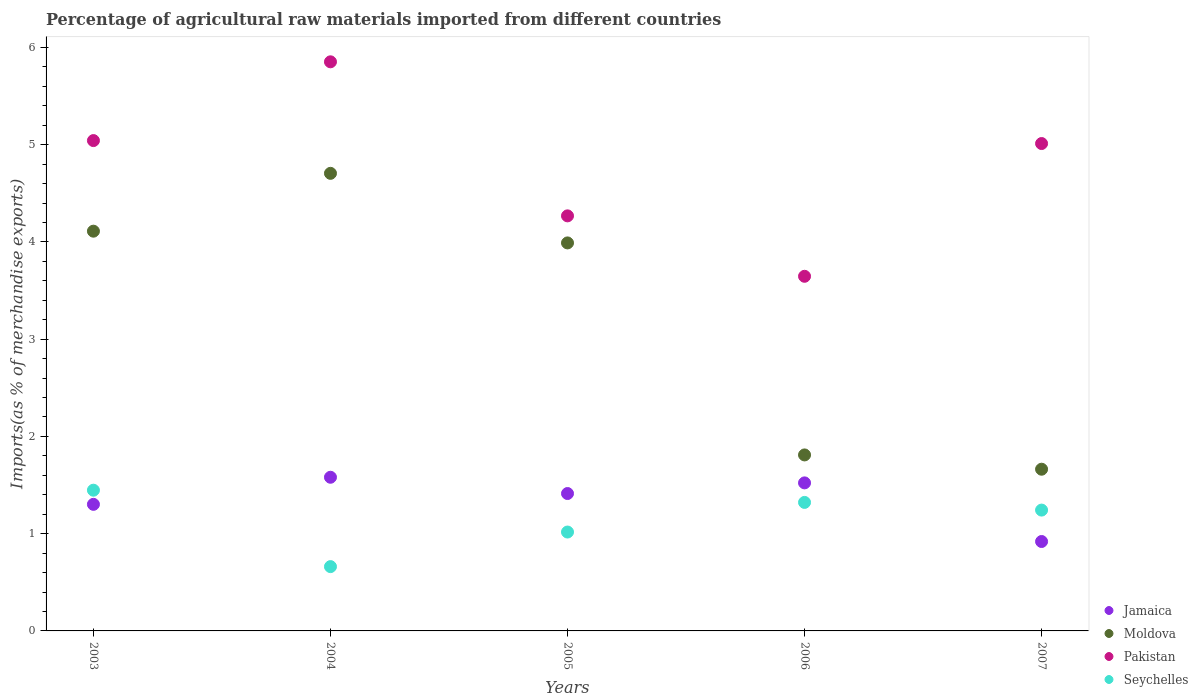How many different coloured dotlines are there?
Give a very brief answer. 4. Is the number of dotlines equal to the number of legend labels?
Provide a short and direct response. Yes. What is the percentage of imports to different countries in Seychelles in 2006?
Offer a very short reply. 1.32. Across all years, what is the maximum percentage of imports to different countries in Jamaica?
Make the answer very short. 1.58. Across all years, what is the minimum percentage of imports to different countries in Jamaica?
Provide a succinct answer. 0.92. In which year was the percentage of imports to different countries in Moldova minimum?
Make the answer very short. 2007. What is the total percentage of imports to different countries in Seychelles in the graph?
Your answer should be very brief. 5.69. What is the difference between the percentage of imports to different countries in Pakistan in 2005 and that in 2006?
Ensure brevity in your answer.  0.62. What is the difference between the percentage of imports to different countries in Seychelles in 2006 and the percentage of imports to different countries in Pakistan in 2004?
Your answer should be very brief. -4.53. What is the average percentage of imports to different countries in Moldova per year?
Give a very brief answer. 3.26. In the year 2007, what is the difference between the percentage of imports to different countries in Moldova and percentage of imports to different countries in Jamaica?
Provide a succinct answer. 0.74. In how many years, is the percentage of imports to different countries in Moldova greater than 4.2 %?
Make the answer very short. 1. What is the ratio of the percentage of imports to different countries in Seychelles in 2004 to that in 2007?
Your response must be concise. 0.53. What is the difference between the highest and the second highest percentage of imports to different countries in Pakistan?
Provide a succinct answer. 0.81. What is the difference between the highest and the lowest percentage of imports to different countries in Pakistan?
Your response must be concise. 2.21. In how many years, is the percentage of imports to different countries in Jamaica greater than the average percentage of imports to different countries in Jamaica taken over all years?
Give a very brief answer. 3. Is it the case that in every year, the sum of the percentage of imports to different countries in Jamaica and percentage of imports to different countries in Moldova  is greater than the sum of percentage of imports to different countries in Pakistan and percentage of imports to different countries in Seychelles?
Give a very brief answer. No. Is it the case that in every year, the sum of the percentage of imports to different countries in Seychelles and percentage of imports to different countries in Jamaica  is greater than the percentage of imports to different countries in Pakistan?
Provide a short and direct response. No. Does the percentage of imports to different countries in Seychelles monotonically increase over the years?
Provide a short and direct response. No. Is the percentage of imports to different countries in Seychelles strictly greater than the percentage of imports to different countries in Moldova over the years?
Make the answer very short. No. Is the percentage of imports to different countries in Jamaica strictly less than the percentage of imports to different countries in Pakistan over the years?
Ensure brevity in your answer.  Yes. How many dotlines are there?
Your answer should be very brief. 4. What is the difference between two consecutive major ticks on the Y-axis?
Provide a succinct answer. 1. Are the values on the major ticks of Y-axis written in scientific E-notation?
Offer a terse response. No. Does the graph contain any zero values?
Offer a very short reply. No. Does the graph contain grids?
Keep it short and to the point. No. Where does the legend appear in the graph?
Provide a short and direct response. Bottom right. How many legend labels are there?
Your answer should be very brief. 4. How are the legend labels stacked?
Offer a very short reply. Vertical. What is the title of the graph?
Keep it short and to the point. Percentage of agricultural raw materials imported from different countries. Does "Upper middle income" appear as one of the legend labels in the graph?
Your answer should be very brief. No. What is the label or title of the X-axis?
Offer a very short reply. Years. What is the label or title of the Y-axis?
Ensure brevity in your answer.  Imports(as % of merchandise exports). What is the Imports(as % of merchandise exports) of Jamaica in 2003?
Your answer should be very brief. 1.3. What is the Imports(as % of merchandise exports) in Moldova in 2003?
Make the answer very short. 4.11. What is the Imports(as % of merchandise exports) of Pakistan in 2003?
Offer a very short reply. 5.04. What is the Imports(as % of merchandise exports) of Seychelles in 2003?
Provide a succinct answer. 1.45. What is the Imports(as % of merchandise exports) of Jamaica in 2004?
Offer a terse response. 1.58. What is the Imports(as % of merchandise exports) of Moldova in 2004?
Ensure brevity in your answer.  4.71. What is the Imports(as % of merchandise exports) of Pakistan in 2004?
Your answer should be very brief. 5.85. What is the Imports(as % of merchandise exports) of Seychelles in 2004?
Your answer should be very brief. 0.66. What is the Imports(as % of merchandise exports) of Jamaica in 2005?
Provide a succinct answer. 1.41. What is the Imports(as % of merchandise exports) of Moldova in 2005?
Your answer should be compact. 3.99. What is the Imports(as % of merchandise exports) in Pakistan in 2005?
Your answer should be compact. 4.27. What is the Imports(as % of merchandise exports) of Seychelles in 2005?
Make the answer very short. 1.02. What is the Imports(as % of merchandise exports) of Jamaica in 2006?
Offer a very short reply. 1.52. What is the Imports(as % of merchandise exports) in Moldova in 2006?
Your answer should be very brief. 1.81. What is the Imports(as % of merchandise exports) in Pakistan in 2006?
Ensure brevity in your answer.  3.65. What is the Imports(as % of merchandise exports) of Seychelles in 2006?
Ensure brevity in your answer.  1.32. What is the Imports(as % of merchandise exports) in Jamaica in 2007?
Your response must be concise. 0.92. What is the Imports(as % of merchandise exports) in Moldova in 2007?
Ensure brevity in your answer.  1.66. What is the Imports(as % of merchandise exports) in Pakistan in 2007?
Ensure brevity in your answer.  5.01. What is the Imports(as % of merchandise exports) of Seychelles in 2007?
Make the answer very short. 1.24. Across all years, what is the maximum Imports(as % of merchandise exports) of Jamaica?
Offer a terse response. 1.58. Across all years, what is the maximum Imports(as % of merchandise exports) of Moldova?
Make the answer very short. 4.71. Across all years, what is the maximum Imports(as % of merchandise exports) of Pakistan?
Ensure brevity in your answer.  5.85. Across all years, what is the maximum Imports(as % of merchandise exports) of Seychelles?
Provide a short and direct response. 1.45. Across all years, what is the minimum Imports(as % of merchandise exports) of Jamaica?
Make the answer very short. 0.92. Across all years, what is the minimum Imports(as % of merchandise exports) in Moldova?
Offer a terse response. 1.66. Across all years, what is the minimum Imports(as % of merchandise exports) of Pakistan?
Provide a succinct answer. 3.65. Across all years, what is the minimum Imports(as % of merchandise exports) of Seychelles?
Your answer should be very brief. 0.66. What is the total Imports(as % of merchandise exports) in Jamaica in the graph?
Make the answer very short. 6.74. What is the total Imports(as % of merchandise exports) in Moldova in the graph?
Your answer should be very brief. 16.28. What is the total Imports(as % of merchandise exports) in Pakistan in the graph?
Provide a succinct answer. 23.82. What is the total Imports(as % of merchandise exports) in Seychelles in the graph?
Your answer should be compact. 5.69. What is the difference between the Imports(as % of merchandise exports) of Jamaica in 2003 and that in 2004?
Provide a succinct answer. -0.28. What is the difference between the Imports(as % of merchandise exports) in Moldova in 2003 and that in 2004?
Offer a very short reply. -0.59. What is the difference between the Imports(as % of merchandise exports) of Pakistan in 2003 and that in 2004?
Provide a succinct answer. -0.81. What is the difference between the Imports(as % of merchandise exports) in Seychelles in 2003 and that in 2004?
Offer a terse response. 0.79. What is the difference between the Imports(as % of merchandise exports) in Jamaica in 2003 and that in 2005?
Provide a short and direct response. -0.11. What is the difference between the Imports(as % of merchandise exports) in Moldova in 2003 and that in 2005?
Your answer should be compact. 0.12. What is the difference between the Imports(as % of merchandise exports) in Pakistan in 2003 and that in 2005?
Provide a short and direct response. 0.77. What is the difference between the Imports(as % of merchandise exports) of Seychelles in 2003 and that in 2005?
Provide a succinct answer. 0.43. What is the difference between the Imports(as % of merchandise exports) in Jamaica in 2003 and that in 2006?
Make the answer very short. -0.22. What is the difference between the Imports(as % of merchandise exports) of Moldova in 2003 and that in 2006?
Your answer should be very brief. 2.3. What is the difference between the Imports(as % of merchandise exports) in Pakistan in 2003 and that in 2006?
Provide a succinct answer. 1.4. What is the difference between the Imports(as % of merchandise exports) in Seychelles in 2003 and that in 2006?
Make the answer very short. 0.13. What is the difference between the Imports(as % of merchandise exports) in Jamaica in 2003 and that in 2007?
Your answer should be very brief. 0.38. What is the difference between the Imports(as % of merchandise exports) in Moldova in 2003 and that in 2007?
Offer a very short reply. 2.45. What is the difference between the Imports(as % of merchandise exports) of Pakistan in 2003 and that in 2007?
Make the answer very short. 0.03. What is the difference between the Imports(as % of merchandise exports) of Seychelles in 2003 and that in 2007?
Keep it short and to the point. 0.2. What is the difference between the Imports(as % of merchandise exports) in Jamaica in 2004 and that in 2005?
Your response must be concise. 0.17. What is the difference between the Imports(as % of merchandise exports) in Moldova in 2004 and that in 2005?
Provide a short and direct response. 0.72. What is the difference between the Imports(as % of merchandise exports) of Pakistan in 2004 and that in 2005?
Ensure brevity in your answer.  1.58. What is the difference between the Imports(as % of merchandise exports) in Seychelles in 2004 and that in 2005?
Offer a very short reply. -0.36. What is the difference between the Imports(as % of merchandise exports) in Jamaica in 2004 and that in 2006?
Give a very brief answer. 0.06. What is the difference between the Imports(as % of merchandise exports) in Moldova in 2004 and that in 2006?
Your answer should be very brief. 2.9. What is the difference between the Imports(as % of merchandise exports) of Pakistan in 2004 and that in 2006?
Your response must be concise. 2.21. What is the difference between the Imports(as % of merchandise exports) of Seychelles in 2004 and that in 2006?
Give a very brief answer. -0.66. What is the difference between the Imports(as % of merchandise exports) in Jamaica in 2004 and that in 2007?
Provide a succinct answer. 0.66. What is the difference between the Imports(as % of merchandise exports) in Moldova in 2004 and that in 2007?
Offer a very short reply. 3.04. What is the difference between the Imports(as % of merchandise exports) in Pakistan in 2004 and that in 2007?
Make the answer very short. 0.84. What is the difference between the Imports(as % of merchandise exports) in Seychelles in 2004 and that in 2007?
Give a very brief answer. -0.58. What is the difference between the Imports(as % of merchandise exports) of Jamaica in 2005 and that in 2006?
Make the answer very short. -0.11. What is the difference between the Imports(as % of merchandise exports) in Moldova in 2005 and that in 2006?
Offer a very short reply. 2.18. What is the difference between the Imports(as % of merchandise exports) in Pakistan in 2005 and that in 2006?
Offer a terse response. 0.62. What is the difference between the Imports(as % of merchandise exports) of Seychelles in 2005 and that in 2006?
Your response must be concise. -0.3. What is the difference between the Imports(as % of merchandise exports) of Jamaica in 2005 and that in 2007?
Keep it short and to the point. 0.49. What is the difference between the Imports(as % of merchandise exports) of Moldova in 2005 and that in 2007?
Your response must be concise. 2.33. What is the difference between the Imports(as % of merchandise exports) in Pakistan in 2005 and that in 2007?
Your answer should be compact. -0.74. What is the difference between the Imports(as % of merchandise exports) of Seychelles in 2005 and that in 2007?
Your response must be concise. -0.23. What is the difference between the Imports(as % of merchandise exports) of Jamaica in 2006 and that in 2007?
Keep it short and to the point. 0.6. What is the difference between the Imports(as % of merchandise exports) of Moldova in 2006 and that in 2007?
Provide a succinct answer. 0.15. What is the difference between the Imports(as % of merchandise exports) in Pakistan in 2006 and that in 2007?
Your answer should be compact. -1.37. What is the difference between the Imports(as % of merchandise exports) of Seychelles in 2006 and that in 2007?
Ensure brevity in your answer.  0.08. What is the difference between the Imports(as % of merchandise exports) of Jamaica in 2003 and the Imports(as % of merchandise exports) of Moldova in 2004?
Offer a very short reply. -3.4. What is the difference between the Imports(as % of merchandise exports) of Jamaica in 2003 and the Imports(as % of merchandise exports) of Pakistan in 2004?
Offer a terse response. -4.55. What is the difference between the Imports(as % of merchandise exports) in Jamaica in 2003 and the Imports(as % of merchandise exports) in Seychelles in 2004?
Give a very brief answer. 0.64. What is the difference between the Imports(as % of merchandise exports) in Moldova in 2003 and the Imports(as % of merchandise exports) in Pakistan in 2004?
Your answer should be compact. -1.74. What is the difference between the Imports(as % of merchandise exports) in Moldova in 2003 and the Imports(as % of merchandise exports) in Seychelles in 2004?
Keep it short and to the point. 3.45. What is the difference between the Imports(as % of merchandise exports) in Pakistan in 2003 and the Imports(as % of merchandise exports) in Seychelles in 2004?
Your answer should be compact. 4.38. What is the difference between the Imports(as % of merchandise exports) of Jamaica in 2003 and the Imports(as % of merchandise exports) of Moldova in 2005?
Give a very brief answer. -2.69. What is the difference between the Imports(as % of merchandise exports) of Jamaica in 2003 and the Imports(as % of merchandise exports) of Pakistan in 2005?
Your answer should be very brief. -2.97. What is the difference between the Imports(as % of merchandise exports) of Jamaica in 2003 and the Imports(as % of merchandise exports) of Seychelles in 2005?
Ensure brevity in your answer.  0.28. What is the difference between the Imports(as % of merchandise exports) of Moldova in 2003 and the Imports(as % of merchandise exports) of Pakistan in 2005?
Your answer should be compact. -0.16. What is the difference between the Imports(as % of merchandise exports) of Moldova in 2003 and the Imports(as % of merchandise exports) of Seychelles in 2005?
Provide a short and direct response. 3.09. What is the difference between the Imports(as % of merchandise exports) in Pakistan in 2003 and the Imports(as % of merchandise exports) in Seychelles in 2005?
Your answer should be very brief. 4.03. What is the difference between the Imports(as % of merchandise exports) of Jamaica in 2003 and the Imports(as % of merchandise exports) of Moldova in 2006?
Offer a very short reply. -0.51. What is the difference between the Imports(as % of merchandise exports) in Jamaica in 2003 and the Imports(as % of merchandise exports) in Pakistan in 2006?
Offer a terse response. -2.35. What is the difference between the Imports(as % of merchandise exports) in Jamaica in 2003 and the Imports(as % of merchandise exports) in Seychelles in 2006?
Your response must be concise. -0.02. What is the difference between the Imports(as % of merchandise exports) of Moldova in 2003 and the Imports(as % of merchandise exports) of Pakistan in 2006?
Your answer should be compact. 0.46. What is the difference between the Imports(as % of merchandise exports) of Moldova in 2003 and the Imports(as % of merchandise exports) of Seychelles in 2006?
Keep it short and to the point. 2.79. What is the difference between the Imports(as % of merchandise exports) of Pakistan in 2003 and the Imports(as % of merchandise exports) of Seychelles in 2006?
Provide a short and direct response. 3.72. What is the difference between the Imports(as % of merchandise exports) in Jamaica in 2003 and the Imports(as % of merchandise exports) in Moldova in 2007?
Ensure brevity in your answer.  -0.36. What is the difference between the Imports(as % of merchandise exports) in Jamaica in 2003 and the Imports(as % of merchandise exports) in Pakistan in 2007?
Keep it short and to the point. -3.71. What is the difference between the Imports(as % of merchandise exports) of Jamaica in 2003 and the Imports(as % of merchandise exports) of Seychelles in 2007?
Ensure brevity in your answer.  0.06. What is the difference between the Imports(as % of merchandise exports) in Moldova in 2003 and the Imports(as % of merchandise exports) in Pakistan in 2007?
Provide a succinct answer. -0.9. What is the difference between the Imports(as % of merchandise exports) of Moldova in 2003 and the Imports(as % of merchandise exports) of Seychelles in 2007?
Your answer should be compact. 2.87. What is the difference between the Imports(as % of merchandise exports) in Pakistan in 2003 and the Imports(as % of merchandise exports) in Seychelles in 2007?
Keep it short and to the point. 3.8. What is the difference between the Imports(as % of merchandise exports) of Jamaica in 2004 and the Imports(as % of merchandise exports) of Moldova in 2005?
Make the answer very short. -2.41. What is the difference between the Imports(as % of merchandise exports) in Jamaica in 2004 and the Imports(as % of merchandise exports) in Pakistan in 2005?
Provide a short and direct response. -2.69. What is the difference between the Imports(as % of merchandise exports) in Jamaica in 2004 and the Imports(as % of merchandise exports) in Seychelles in 2005?
Keep it short and to the point. 0.56. What is the difference between the Imports(as % of merchandise exports) in Moldova in 2004 and the Imports(as % of merchandise exports) in Pakistan in 2005?
Your response must be concise. 0.44. What is the difference between the Imports(as % of merchandise exports) of Moldova in 2004 and the Imports(as % of merchandise exports) of Seychelles in 2005?
Provide a short and direct response. 3.69. What is the difference between the Imports(as % of merchandise exports) in Pakistan in 2004 and the Imports(as % of merchandise exports) in Seychelles in 2005?
Make the answer very short. 4.84. What is the difference between the Imports(as % of merchandise exports) in Jamaica in 2004 and the Imports(as % of merchandise exports) in Moldova in 2006?
Ensure brevity in your answer.  -0.23. What is the difference between the Imports(as % of merchandise exports) of Jamaica in 2004 and the Imports(as % of merchandise exports) of Pakistan in 2006?
Your response must be concise. -2.07. What is the difference between the Imports(as % of merchandise exports) of Jamaica in 2004 and the Imports(as % of merchandise exports) of Seychelles in 2006?
Offer a very short reply. 0.26. What is the difference between the Imports(as % of merchandise exports) of Moldova in 2004 and the Imports(as % of merchandise exports) of Pakistan in 2006?
Your answer should be compact. 1.06. What is the difference between the Imports(as % of merchandise exports) of Moldova in 2004 and the Imports(as % of merchandise exports) of Seychelles in 2006?
Provide a succinct answer. 3.38. What is the difference between the Imports(as % of merchandise exports) in Pakistan in 2004 and the Imports(as % of merchandise exports) in Seychelles in 2006?
Your response must be concise. 4.53. What is the difference between the Imports(as % of merchandise exports) in Jamaica in 2004 and the Imports(as % of merchandise exports) in Moldova in 2007?
Your response must be concise. -0.08. What is the difference between the Imports(as % of merchandise exports) in Jamaica in 2004 and the Imports(as % of merchandise exports) in Pakistan in 2007?
Your response must be concise. -3.43. What is the difference between the Imports(as % of merchandise exports) in Jamaica in 2004 and the Imports(as % of merchandise exports) in Seychelles in 2007?
Your response must be concise. 0.34. What is the difference between the Imports(as % of merchandise exports) of Moldova in 2004 and the Imports(as % of merchandise exports) of Pakistan in 2007?
Offer a very short reply. -0.31. What is the difference between the Imports(as % of merchandise exports) of Moldova in 2004 and the Imports(as % of merchandise exports) of Seychelles in 2007?
Ensure brevity in your answer.  3.46. What is the difference between the Imports(as % of merchandise exports) in Pakistan in 2004 and the Imports(as % of merchandise exports) in Seychelles in 2007?
Ensure brevity in your answer.  4.61. What is the difference between the Imports(as % of merchandise exports) of Jamaica in 2005 and the Imports(as % of merchandise exports) of Moldova in 2006?
Give a very brief answer. -0.4. What is the difference between the Imports(as % of merchandise exports) of Jamaica in 2005 and the Imports(as % of merchandise exports) of Pakistan in 2006?
Provide a short and direct response. -2.23. What is the difference between the Imports(as % of merchandise exports) of Jamaica in 2005 and the Imports(as % of merchandise exports) of Seychelles in 2006?
Give a very brief answer. 0.09. What is the difference between the Imports(as % of merchandise exports) of Moldova in 2005 and the Imports(as % of merchandise exports) of Pakistan in 2006?
Ensure brevity in your answer.  0.34. What is the difference between the Imports(as % of merchandise exports) in Moldova in 2005 and the Imports(as % of merchandise exports) in Seychelles in 2006?
Provide a succinct answer. 2.67. What is the difference between the Imports(as % of merchandise exports) in Pakistan in 2005 and the Imports(as % of merchandise exports) in Seychelles in 2006?
Your response must be concise. 2.95. What is the difference between the Imports(as % of merchandise exports) in Jamaica in 2005 and the Imports(as % of merchandise exports) in Pakistan in 2007?
Provide a succinct answer. -3.6. What is the difference between the Imports(as % of merchandise exports) of Jamaica in 2005 and the Imports(as % of merchandise exports) of Seychelles in 2007?
Your answer should be very brief. 0.17. What is the difference between the Imports(as % of merchandise exports) in Moldova in 2005 and the Imports(as % of merchandise exports) in Pakistan in 2007?
Your answer should be very brief. -1.02. What is the difference between the Imports(as % of merchandise exports) in Moldova in 2005 and the Imports(as % of merchandise exports) in Seychelles in 2007?
Give a very brief answer. 2.75. What is the difference between the Imports(as % of merchandise exports) in Pakistan in 2005 and the Imports(as % of merchandise exports) in Seychelles in 2007?
Your answer should be very brief. 3.03. What is the difference between the Imports(as % of merchandise exports) of Jamaica in 2006 and the Imports(as % of merchandise exports) of Moldova in 2007?
Ensure brevity in your answer.  -0.14. What is the difference between the Imports(as % of merchandise exports) of Jamaica in 2006 and the Imports(as % of merchandise exports) of Pakistan in 2007?
Give a very brief answer. -3.49. What is the difference between the Imports(as % of merchandise exports) of Jamaica in 2006 and the Imports(as % of merchandise exports) of Seychelles in 2007?
Give a very brief answer. 0.28. What is the difference between the Imports(as % of merchandise exports) of Moldova in 2006 and the Imports(as % of merchandise exports) of Pakistan in 2007?
Make the answer very short. -3.2. What is the difference between the Imports(as % of merchandise exports) in Moldova in 2006 and the Imports(as % of merchandise exports) in Seychelles in 2007?
Offer a very short reply. 0.57. What is the difference between the Imports(as % of merchandise exports) in Pakistan in 2006 and the Imports(as % of merchandise exports) in Seychelles in 2007?
Provide a short and direct response. 2.4. What is the average Imports(as % of merchandise exports) in Jamaica per year?
Offer a terse response. 1.35. What is the average Imports(as % of merchandise exports) of Moldova per year?
Your answer should be very brief. 3.26. What is the average Imports(as % of merchandise exports) of Pakistan per year?
Your answer should be compact. 4.76. What is the average Imports(as % of merchandise exports) in Seychelles per year?
Provide a short and direct response. 1.14. In the year 2003, what is the difference between the Imports(as % of merchandise exports) in Jamaica and Imports(as % of merchandise exports) in Moldova?
Your answer should be very brief. -2.81. In the year 2003, what is the difference between the Imports(as % of merchandise exports) in Jamaica and Imports(as % of merchandise exports) in Pakistan?
Your answer should be very brief. -3.74. In the year 2003, what is the difference between the Imports(as % of merchandise exports) in Jamaica and Imports(as % of merchandise exports) in Seychelles?
Offer a terse response. -0.15. In the year 2003, what is the difference between the Imports(as % of merchandise exports) in Moldova and Imports(as % of merchandise exports) in Pakistan?
Provide a short and direct response. -0.93. In the year 2003, what is the difference between the Imports(as % of merchandise exports) in Moldova and Imports(as % of merchandise exports) in Seychelles?
Your response must be concise. 2.66. In the year 2003, what is the difference between the Imports(as % of merchandise exports) in Pakistan and Imports(as % of merchandise exports) in Seychelles?
Offer a very short reply. 3.6. In the year 2004, what is the difference between the Imports(as % of merchandise exports) of Jamaica and Imports(as % of merchandise exports) of Moldova?
Offer a terse response. -3.13. In the year 2004, what is the difference between the Imports(as % of merchandise exports) in Jamaica and Imports(as % of merchandise exports) in Pakistan?
Offer a very short reply. -4.27. In the year 2004, what is the difference between the Imports(as % of merchandise exports) of Jamaica and Imports(as % of merchandise exports) of Seychelles?
Provide a short and direct response. 0.92. In the year 2004, what is the difference between the Imports(as % of merchandise exports) of Moldova and Imports(as % of merchandise exports) of Pakistan?
Make the answer very short. -1.15. In the year 2004, what is the difference between the Imports(as % of merchandise exports) in Moldova and Imports(as % of merchandise exports) in Seychelles?
Make the answer very short. 4.04. In the year 2004, what is the difference between the Imports(as % of merchandise exports) in Pakistan and Imports(as % of merchandise exports) in Seychelles?
Your answer should be compact. 5.19. In the year 2005, what is the difference between the Imports(as % of merchandise exports) of Jamaica and Imports(as % of merchandise exports) of Moldova?
Ensure brevity in your answer.  -2.58. In the year 2005, what is the difference between the Imports(as % of merchandise exports) in Jamaica and Imports(as % of merchandise exports) in Pakistan?
Your answer should be very brief. -2.86. In the year 2005, what is the difference between the Imports(as % of merchandise exports) of Jamaica and Imports(as % of merchandise exports) of Seychelles?
Keep it short and to the point. 0.4. In the year 2005, what is the difference between the Imports(as % of merchandise exports) of Moldova and Imports(as % of merchandise exports) of Pakistan?
Offer a very short reply. -0.28. In the year 2005, what is the difference between the Imports(as % of merchandise exports) in Moldova and Imports(as % of merchandise exports) in Seychelles?
Offer a very short reply. 2.97. In the year 2005, what is the difference between the Imports(as % of merchandise exports) of Pakistan and Imports(as % of merchandise exports) of Seychelles?
Keep it short and to the point. 3.25. In the year 2006, what is the difference between the Imports(as % of merchandise exports) of Jamaica and Imports(as % of merchandise exports) of Moldova?
Offer a very short reply. -0.29. In the year 2006, what is the difference between the Imports(as % of merchandise exports) of Jamaica and Imports(as % of merchandise exports) of Pakistan?
Offer a very short reply. -2.12. In the year 2006, what is the difference between the Imports(as % of merchandise exports) of Jamaica and Imports(as % of merchandise exports) of Seychelles?
Make the answer very short. 0.2. In the year 2006, what is the difference between the Imports(as % of merchandise exports) of Moldova and Imports(as % of merchandise exports) of Pakistan?
Make the answer very short. -1.84. In the year 2006, what is the difference between the Imports(as % of merchandise exports) of Moldova and Imports(as % of merchandise exports) of Seychelles?
Keep it short and to the point. 0.49. In the year 2006, what is the difference between the Imports(as % of merchandise exports) of Pakistan and Imports(as % of merchandise exports) of Seychelles?
Provide a short and direct response. 2.33. In the year 2007, what is the difference between the Imports(as % of merchandise exports) of Jamaica and Imports(as % of merchandise exports) of Moldova?
Offer a terse response. -0.74. In the year 2007, what is the difference between the Imports(as % of merchandise exports) in Jamaica and Imports(as % of merchandise exports) in Pakistan?
Keep it short and to the point. -4.09. In the year 2007, what is the difference between the Imports(as % of merchandise exports) of Jamaica and Imports(as % of merchandise exports) of Seychelles?
Ensure brevity in your answer.  -0.32. In the year 2007, what is the difference between the Imports(as % of merchandise exports) in Moldova and Imports(as % of merchandise exports) in Pakistan?
Ensure brevity in your answer.  -3.35. In the year 2007, what is the difference between the Imports(as % of merchandise exports) in Moldova and Imports(as % of merchandise exports) in Seychelles?
Offer a very short reply. 0.42. In the year 2007, what is the difference between the Imports(as % of merchandise exports) of Pakistan and Imports(as % of merchandise exports) of Seychelles?
Make the answer very short. 3.77. What is the ratio of the Imports(as % of merchandise exports) of Jamaica in 2003 to that in 2004?
Your answer should be compact. 0.82. What is the ratio of the Imports(as % of merchandise exports) of Moldova in 2003 to that in 2004?
Provide a short and direct response. 0.87. What is the ratio of the Imports(as % of merchandise exports) of Pakistan in 2003 to that in 2004?
Give a very brief answer. 0.86. What is the ratio of the Imports(as % of merchandise exports) of Seychelles in 2003 to that in 2004?
Your answer should be very brief. 2.19. What is the ratio of the Imports(as % of merchandise exports) in Jamaica in 2003 to that in 2005?
Offer a very short reply. 0.92. What is the ratio of the Imports(as % of merchandise exports) in Moldova in 2003 to that in 2005?
Your response must be concise. 1.03. What is the ratio of the Imports(as % of merchandise exports) in Pakistan in 2003 to that in 2005?
Keep it short and to the point. 1.18. What is the ratio of the Imports(as % of merchandise exports) of Seychelles in 2003 to that in 2005?
Ensure brevity in your answer.  1.42. What is the ratio of the Imports(as % of merchandise exports) of Jamaica in 2003 to that in 2006?
Offer a very short reply. 0.85. What is the ratio of the Imports(as % of merchandise exports) of Moldova in 2003 to that in 2006?
Your response must be concise. 2.27. What is the ratio of the Imports(as % of merchandise exports) of Pakistan in 2003 to that in 2006?
Make the answer very short. 1.38. What is the ratio of the Imports(as % of merchandise exports) in Seychelles in 2003 to that in 2006?
Provide a short and direct response. 1.1. What is the ratio of the Imports(as % of merchandise exports) of Jamaica in 2003 to that in 2007?
Your answer should be compact. 1.42. What is the ratio of the Imports(as % of merchandise exports) of Moldova in 2003 to that in 2007?
Your response must be concise. 2.47. What is the ratio of the Imports(as % of merchandise exports) of Pakistan in 2003 to that in 2007?
Ensure brevity in your answer.  1.01. What is the ratio of the Imports(as % of merchandise exports) in Seychelles in 2003 to that in 2007?
Keep it short and to the point. 1.16. What is the ratio of the Imports(as % of merchandise exports) of Jamaica in 2004 to that in 2005?
Your answer should be compact. 1.12. What is the ratio of the Imports(as % of merchandise exports) in Moldova in 2004 to that in 2005?
Provide a short and direct response. 1.18. What is the ratio of the Imports(as % of merchandise exports) in Pakistan in 2004 to that in 2005?
Provide a short and direct response. 1.37. What is the ratio of the Imports(as % of merchandise exports) in Seychelles in 2004 to that in 2005?
Your answer should be compact. 0.65. What is the ratio of the Imports(as % of merchandise exports) in Jamaica in 2004 to that in 2006?
Keep it short and to the point. 1.04. What is the ratio of the Imports(as % of merchandise exports) of Pakistan in 2004 to that in 2006?
Ensure brevity in your answer.  1.6. What is the ratio of the Imports(as % of merchandise exports) in Seychelles in 2004 to that in 2006?
Your response must be concise. 0.5. What is the ratio of the Imports(as % of merchandise exports) in Jamaica in 2004 to that in 2007?
Provide a short and direct response. 1.72. What is the ratio of the Imports(as % of merchandise exports) in Moldova in 2004 to that in 2007?
Keep it short and to the point. 2.83. What is the ratio of the Imports(as % of merchandise exports) of Pakistan in 2004 to that in 2007?
Keep it short and to the point. 1.17. What is the ratio of the Imports(as % of merchandise exports) in Seychelles in 2004 to that in 2007?
Provide a short and direct response. 0.53. What is the ratio of the Imports(as % of merchandise exports) in Jamaica in 2005 to that in 2006?
Your answer should be compact. 0.93. What is the ratio of the Imports(as % of merchandise exports) in Moldova in 2005 to that in 2006?
Offer a very short reply. 2.2. What is the ratio of the Imports(as % of merchandise exports) in Pakistan in 2005 to that in 2006?
Give a very brief answer. 1.17. What is the ratio of the Imports(as % of merchandise exports) of Seychelles in 2005 to that in 2006?
Keep it short and to the point. 0.77. What is the ratio of the Imports(as % of merchandise exports) of Jamaica in 2005 to that in 2007?
Your answer should be compact. 1.54. What is the ratio of the Imports(as % of merchandise exports) in Moldova in 2005 to that in 2007?
Your response must be concise. 2.4. What is the ratio of the Imports(as % of merchandise exports) of Pakistan in 2005 to that in 2007?
Keep it short and to the point. 0.85. What is the ratio of the Imports(as % of merchandise exports) in Seychelles in 2005 to that in 2007?
Provide a short and direct response. 0.82. What is the ratio of the Imports(as % of merchandise exports) of Jamaica in 2006 to that in 2007?
Make the answer very short. 1.66. What is the ratio of the Imports(as % of merchandise exports) in Moldova in 2006 to that in 2007?
Provide a short and direct response. 1.09. What is the ratio of the Imports(as % of merchandise exports) in Pakistan in 2006 to that in 2007?
Provide a succinct answer. 0.73. What is the ratio of the Imports(as % of merchandise exports) of Seychelles in 2006 to that in 2007?
Your answer should be very brief. 1.06. What is the difference between the highest and the second highest Imports(as % of merchandise exports) of Jamaica?
Your response must be concise. 0.06. What is the difference between the highest and the second highest Imports(as % of merchandise exports) of Moldova?
Provide a short and direct response. 0.59. What is the difference between the highest and the second highest Imports(as % of merchandise exports) in Pakistan?
Ensure brevity in your answer.  0.81. What is the difference between the highest and the second highest Imports(as % of merchandise exports) of Seychelles?
Give a very brief answer. 0.13. What is the difference between the highest and the lowest Imports(as % of merchandise exports) of Jamaica?
Give a very brief answer. 0.66. What is the difference between the highest and the lowest Imports(as % of merchandise exports) of Moldova?
Provide a short and direct response. 3.04. What is the difference between the highest and the lowest Imports(as % of merchandise exports) of Pakistan?
Provide a succinct answer. 2.21. What is the difference between the highest and the lowest Imports(as % of merchandise exports) of Seychelles?
Give a very brief answer. 0.79. 